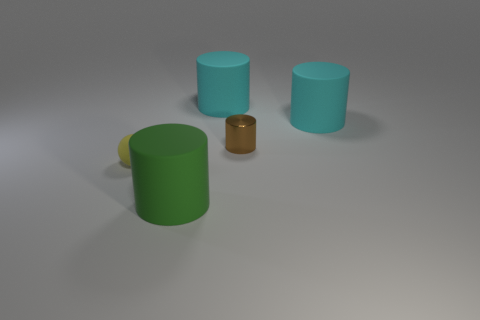How many small yellow matte balls are behind the object left of the large matte thing that is in front of the small cylinder?
Offer a very short reply. 0. Are there any other things that have the same color as the shiny cylinder?
Provide a short and direct response. No. Is the size of the matte object that is left of the green matte cylinder the same as the green rubber thing?
Provide a succinct answer. No. There is a object in front of the yellow rubber ball; what number of things are to the left of it?
Your answer should be very brief. 1. Are there any big cyan cylinders that are left of the thing that is left of the large matte cylinder that is in front of the tiny brown shiny cylinder?
Provide a short and direct response. No. There is another green object that is the same shape as the small metal thing; what is it made of?
Offer a terse response. Rubber. Is there any other thing that has the same material as the sphere?
Offer a very short reply. Yes. Are the large green cylinder and the tiny object right of the green object made of the same material?
Provide a short and direct response. No. The thing to the left of the big matte object in front of the yellow sphere is what shape?
Your answer should be compact. Sphere. How many large objects are blue rubber blocks or brown cylinders?
Offer a terse response. 0. 